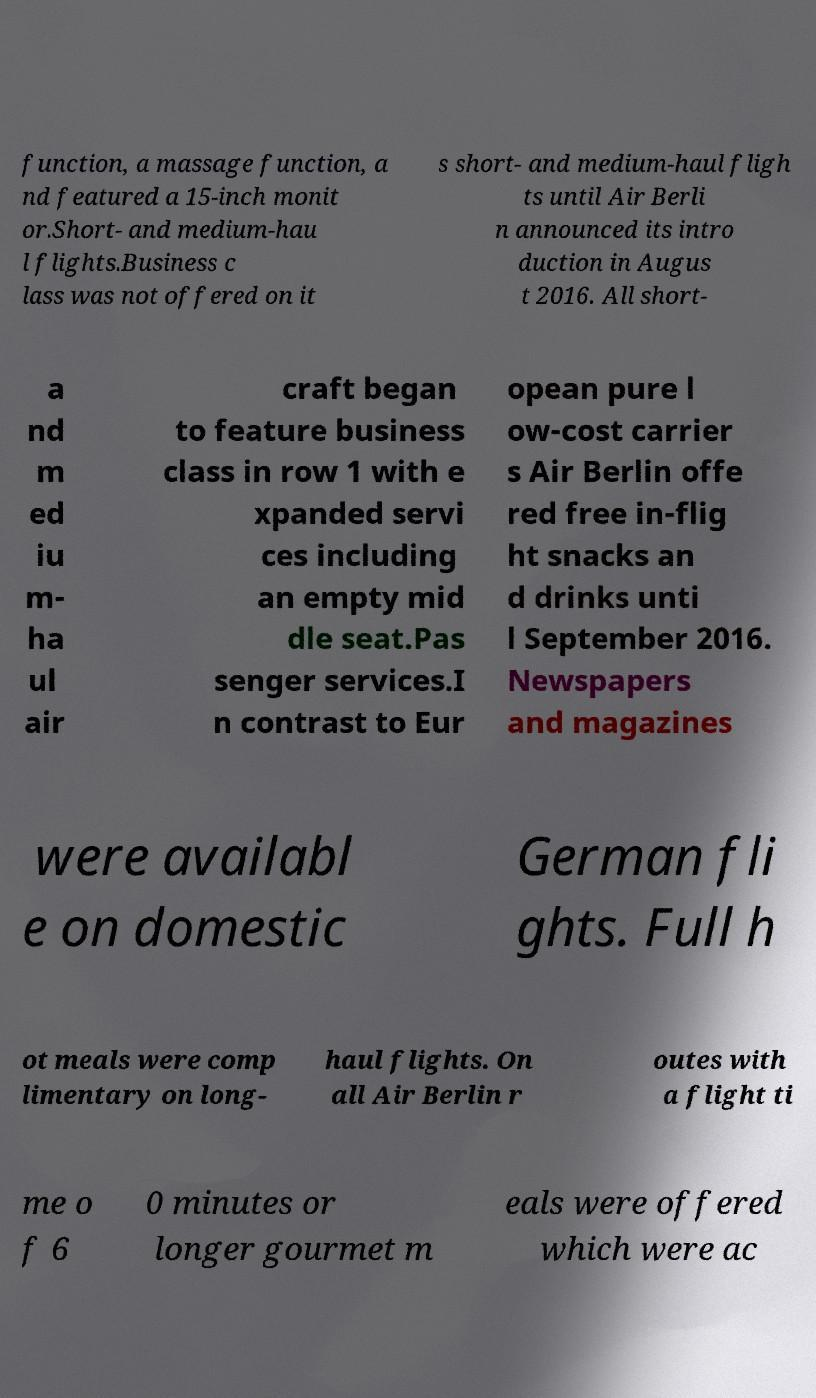Please read and relay the text visible in this image. What does it say? function, a massage function, a nd featured a 15-inch monit or.Short- and medium-hau l flights.Business c lass was not offered on it s short- and medium-haul fligh ts until Air Berli n announced its intro duction in Augus t 2016. All short- a nd m ed iu m- ha ul air craft began to feature business class in row 1 with e xpanded servi ces including an empty mid dle seat.Pas senger services.I n contrast to Eur opean pure l ow-cost carrier s Air Berlin offe red free in-flig ht snacks an d drinks unti l September 2016. Newspapers and magazines were availabl e on domestic German fli ghts. Full h ot meals were comp limentary on long- haul flights. On all Air Berlin r outes with a flight ti me o f 6 0 minutes or longer gourmet m eals were offered which were ac 